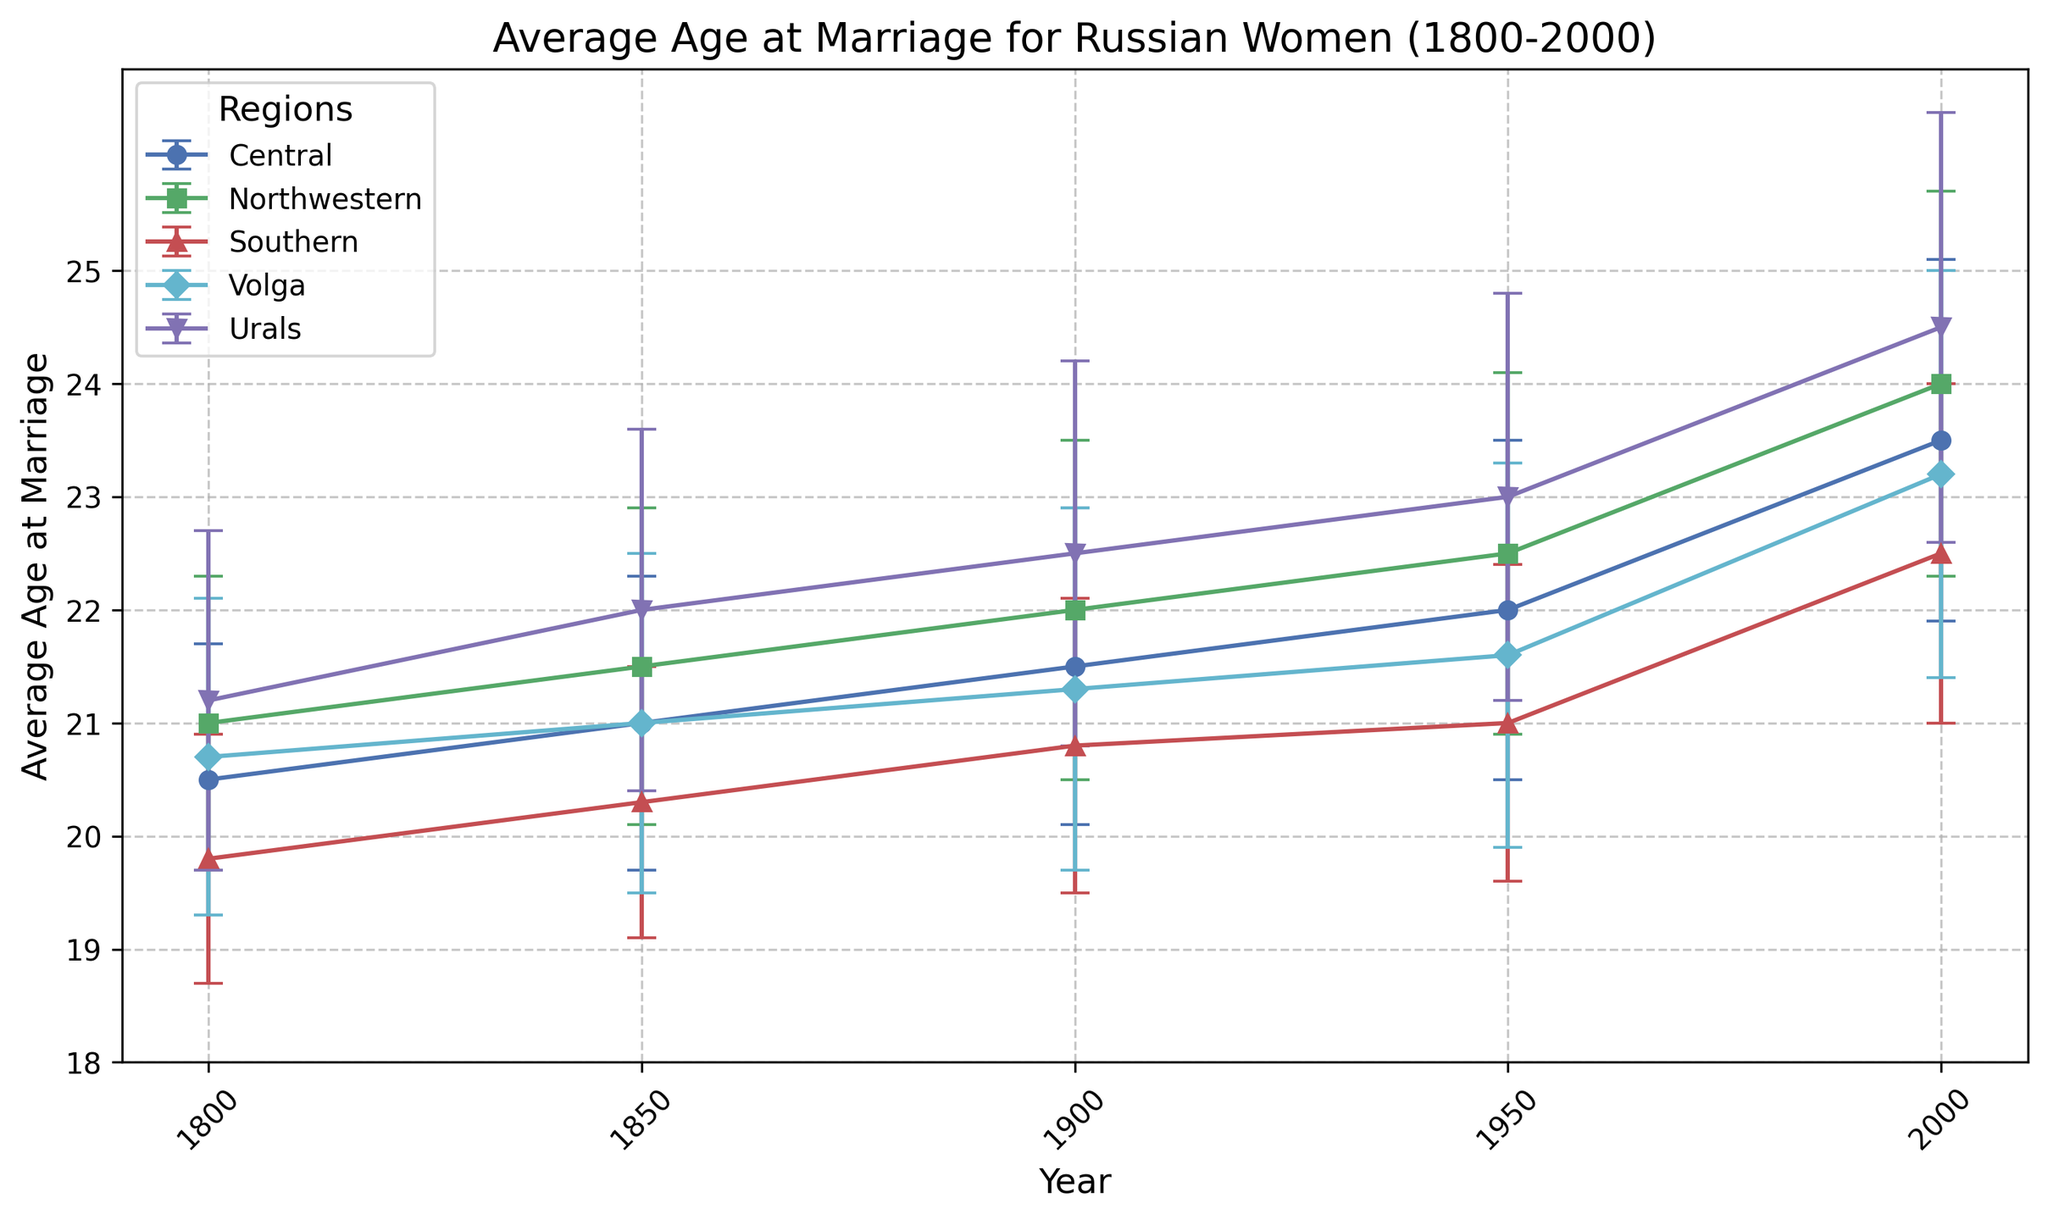What is the average age at marriage for Russian women in the Central region in 2000? Locate the data points for the Central region along the 2000 vertical line. The average age for Central in 2000 is plotted as 23.5
Answer: 23.5 Which region had the highest average age at marriage in 1950? To find this, identify the year 1950 on the x-axis and compare the heights of all data points across regions. The highest is Urals at 23.0
Answer: Urals What is the difference in average age at marriage between the Southern region and the Northwestern region in 1800? For 1800, locate the Southern region (19.8 years) and the Northwestern region (21.0 years). Calculate the difference: 21.0 - 19.8 = 1.2
Answer: 1.2 How has the average age at marriage in the Southern region changed from 1850 to 2000? Follow the Southern region data points from 1850 (20.3) to 2000 (22.5). Calculate the difference: 22.5 - 20.3 = 2.2
Answer: 2.2 Which region showed the greatest increase in average age at marriage from 1900 to 2000? Compare the differences in average ages from 1900 to 2000 for all regions. The Urals increased from 22.5 to 24.5 (increase of 2.0), which is the greatest
Answer: Urals What is the average of the average ages at marriage across all regions in 1800? Average age for 1800 by summing the ages and dividing by the number of regions: (20.5 + 21.0 + 19.8 + 20.7 + 21.2) / 5 = 20.64
Answer: 20.64 Which region has the smallest standard deviation in average age at marriage in 1950? Identify the standard deviations for all regions in 1950 and select the smallest: Southern with a standard deviation of 1.4
Answer: Southern Between 1800 and 2000, which period saw the smallest increase in average age at marriage for the Central region? Calculate the increases for each period in the Central region: 
- 1800 to 1850: 21.0 - 20.5 = 0.5
- 1850 to 1900: 21.5 - 21.0 = 0.5
- 1900 to 1950: 22.0 - 21.5 = 0.5
- 1950 to 2000: 23.5 - 22.0 = 1.5 
The smallest increase occurred in each of the first three periods (1800-1850, 1850-1900, and 1900-1950)
Answer: 0.5 (1800-1850, 1850-1900, and 1900-1950) How consistent are the average ages at marriage for the Urals region across the years depicted? Look at the error bars (standard deviations) for the Urals over the years (1800, 1850, 1900, 1950, 2000). Wider error bars indicate less consistency. Urals has a standard deviation increasing from 1.5 to 1.9, indicating increasing variance over time
Answer: Increasing variance 